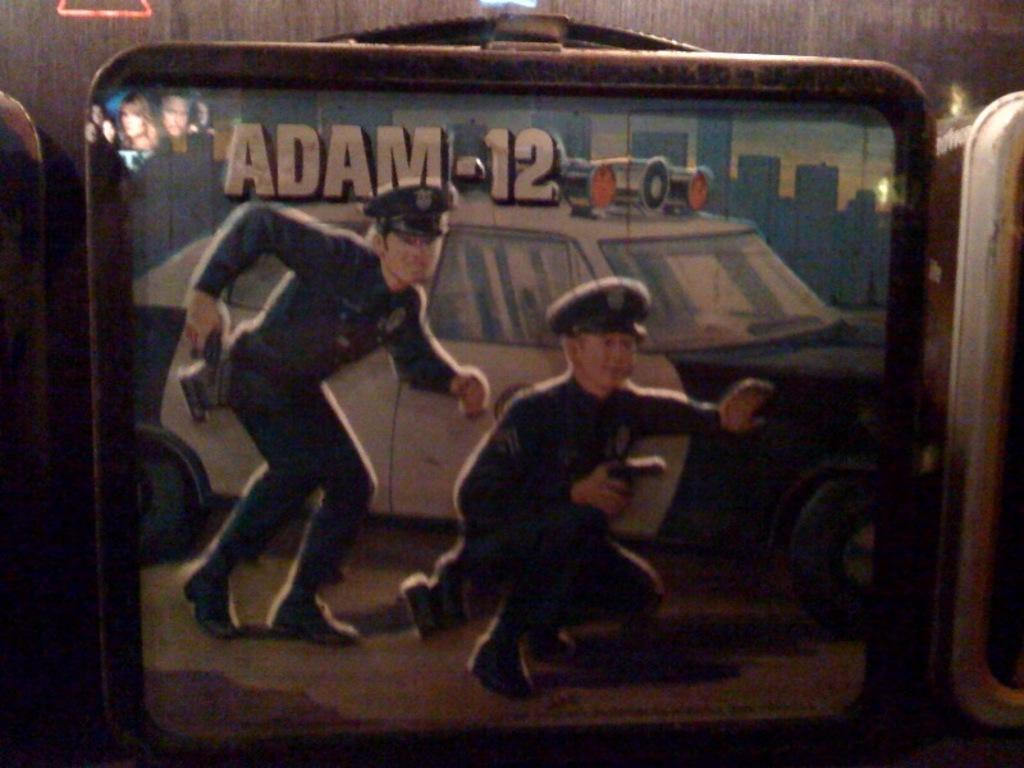What is present on the wall in the image? There is a poster on the wall in the image. What is depicted on the poster? The poster contains an image of a car and two police officers. Are there any buildings visible in the poster? Yes, there are buildings visible behind the car in the poster. What type of match is being played in the image? There is no match being played in the image; it features a poster with an image of a car and two police officers. Can you describe the texture of the police officers' uniforms in the image? The image is not detailed enough to determine the texture of the police officers' uniforms. 